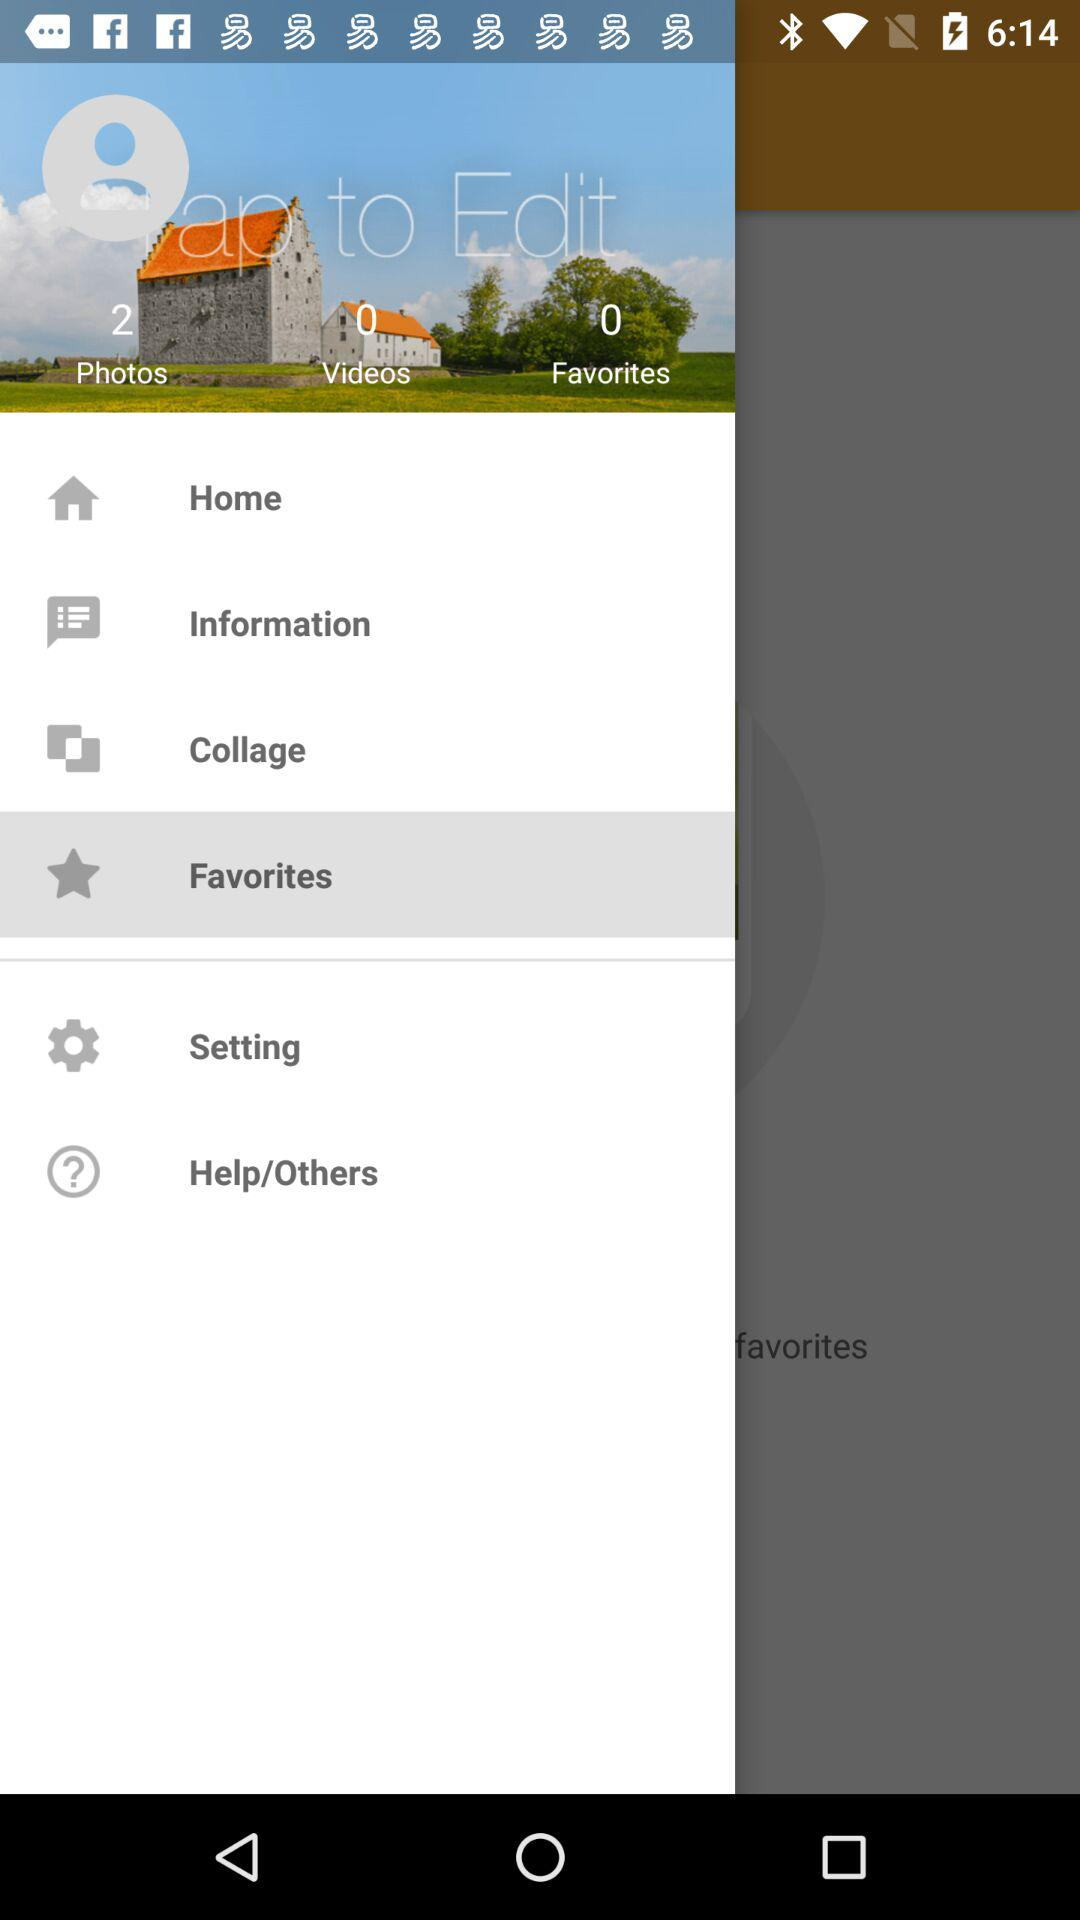How many videos are there? There are 0 videos. 